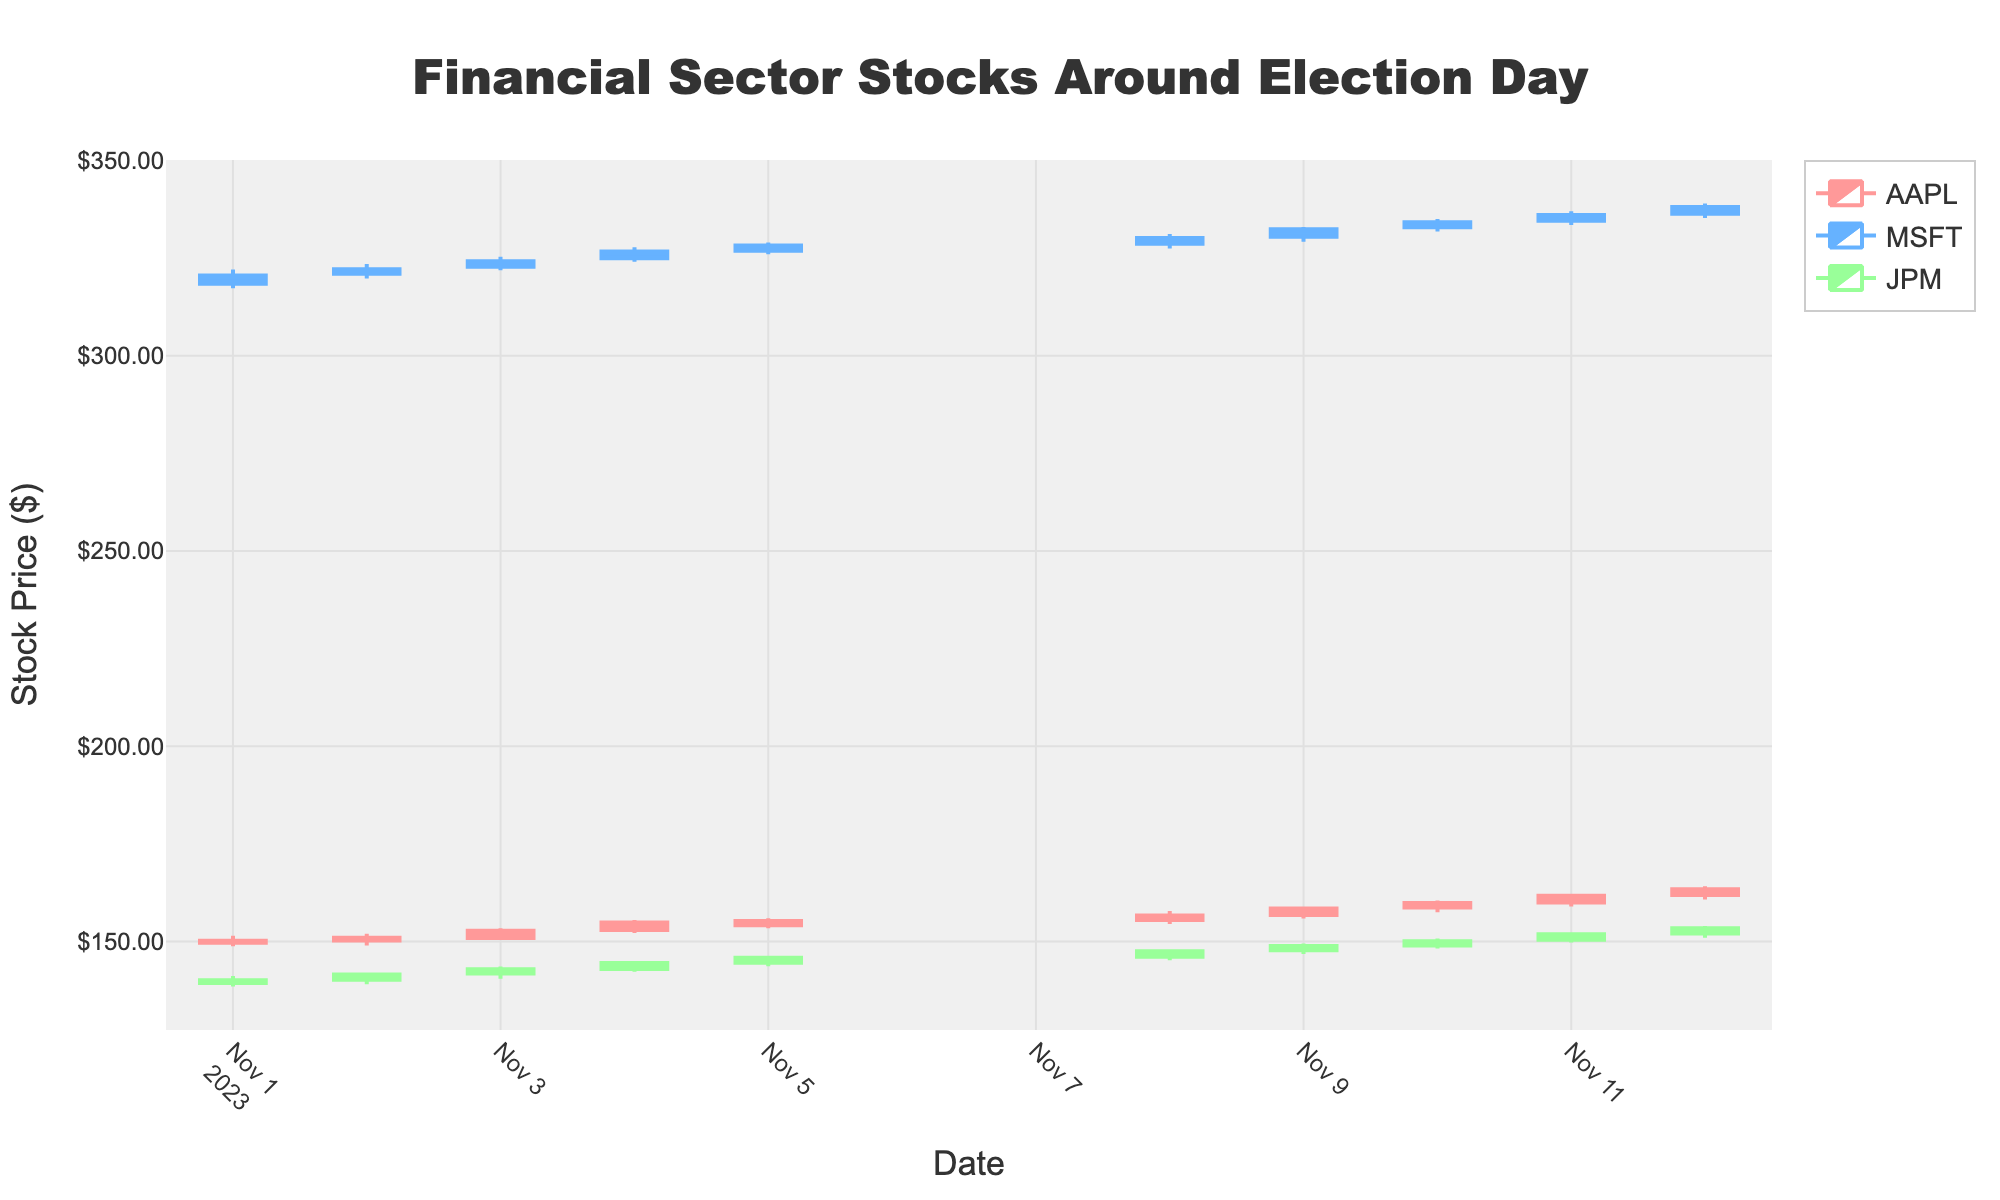What is the title of the figure? The title of the figure is located at the top and centered. It reads "Financial Sector Stocks Around Election Day".
Answer: Financial Sector Stocks Around Election Day How many stocks are represented in the figure? By analyzing the legends and the number of unique traces, we can see that there are three stocks mentioned: AAPL, MSFT, and JPM.
Answer: 3 Which stock had the highest closing price on 2023-11-09? To find this, check the closing prices for each stock on 2023-11-09. The closing prices are 158.45 for AAPL, 332.40 for MSFT, and 148.90 for JPM. MSFT has the highest closing price.
Answer: MSFT What was the lowest price for AAPL on 2023-11-08? For AAPL on 2023-11-08, the lowest price listed in the candlestick data is $154.50.
Answer: $154.50 What is the average closing price of JPM between 2023-11-01 and 2023-11-12? To calculate the average closing price, sum the closing prices for JPM on each day provided and then divide by the number of trading days. The closing prices are 140.11, 141.55, 142.90, 144.50, 145.85, 147.55, 148.90, 150.10, 151.90, and 153.40. The sum is 1416.76, and there are 10 trading days, so the average is 1416.76/10 = 141.68.
Answer: 141.68 Between MSFT and JPM, which stock had a greater change in closing price from 2023-11-01 to 2023-11-12? Calculate the change in closing price for each stock. For MSFT, the change is 338.10 - 320.59 = 17.51. For JPM, the change is 153.40 - 140.11 = 13.29. MSFT had a greater change.
Answer: MSFT Was there a day when AAPL and MSFT both had increasing candlesticks? An increasing candlestick indicates a higher closing price than the opening price. By reviewing each day for both AAPL and MSFT, we find that on 2023-11-05, both had increasing candlesticks since their closing prices were higher than their opening prices.
Answer: Yes What can be inferred from the stock price movements of JPM around the election day on 2023-11-08? Looking at the JPM data, there is a noticeable increase in closing price from 141.55 on 2023-11-02 to 147.55 on 2023-11-08, and it continued to rise to 153.40 by 2023-11-12. This indicates a positive trend around and after the election day.
Answer: Positive trend Among the three stocks, which had the most consistent increase in closing prices from 2023-11-01 to 2023-11-12? To find consistency, we compare the daily closing prices. AAPL has consistent increases from 150.23 to 163.40, MSFT from 320.59 to 338.10, and JPM from 140.11 to 153.40. Consistency refers to fewer fluctuations and steady growth, which AAPL demonstrates most clearly.
Answer: AAPL 